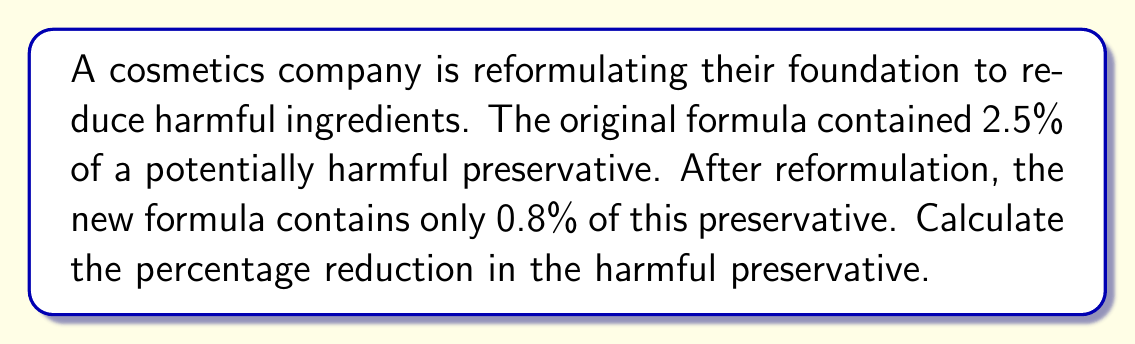Can you answer this question? To calculate the percentage reduction in the harmful preservative, we need to follow these steps:

1. Calculate the absolute reduction:
   Original percentage - New percentage
   $2.5\% - 0.8\% = 1.7\%$

2. Calculate the percentage reduction:
   $\text{Percentage reduction} = \frac{\text{Absolute reduction}}{\text{Original percentage}} \times 100\%$

   Substituting the values:
   $$\text{Percentage reduction} = \frac{1.7\%}{2.5\%} \times 100\%$$

3. Simplify the fraction:
   $$\text{Percentage reduction} = \frac{1.7}{2.5} \times 100\%$$

4. Perform the division:
   $$\text{Percentage reduction} = 0.68 \times 100\% = 68\%$$

Therefore, the percentage reduction in the harmful preservative is 68%.
Answer: 68% 